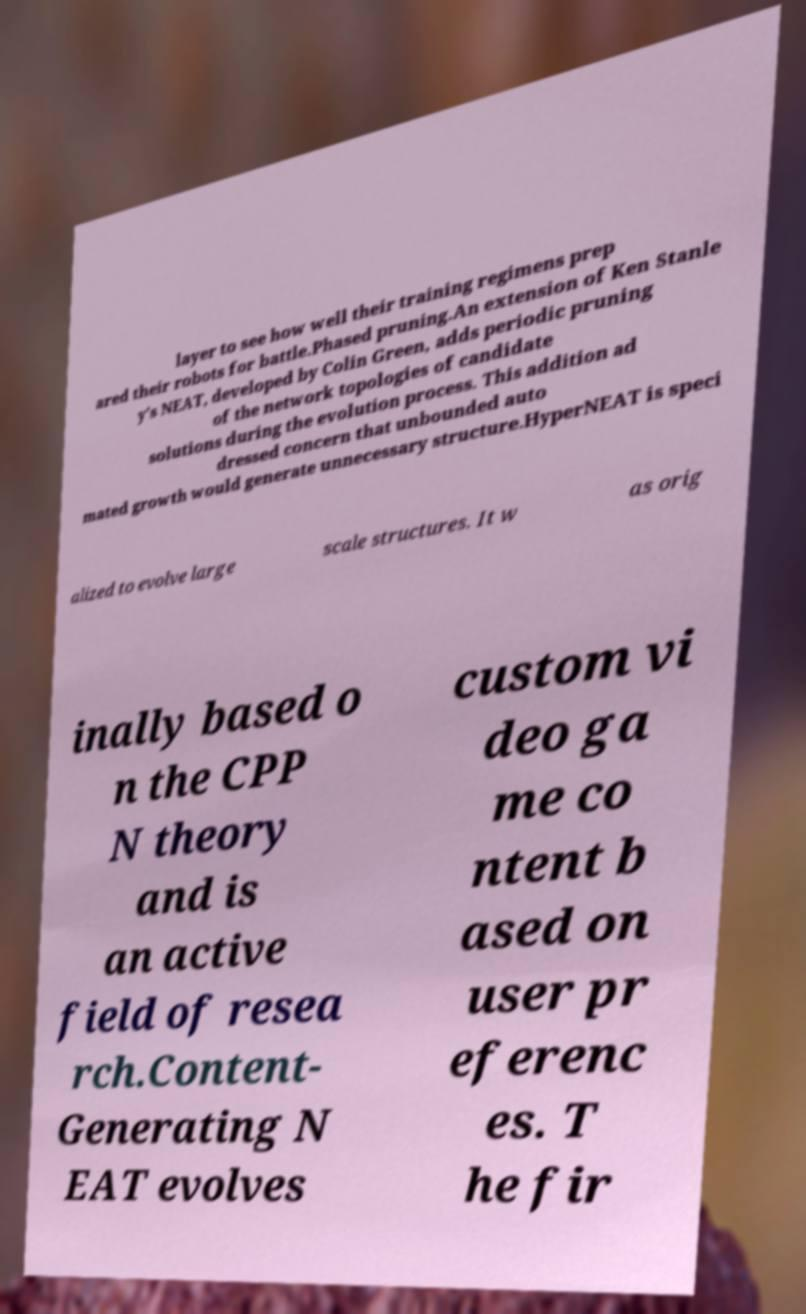Could you assist in decoding the text presented in this image and type it out clearly? layer to see how well their training regimens prep ared their robots for battle.Phased pruning.An extension of Ken Stanle y's NEAT, developed by Colin Green, adds periodic pruning of the network topologies of candidate solutions during the evolution process. This addition ad dressed concern that unbounded auto mated growth would generate unnecessary structure.HyperNEAT is speci alized to evolve large scale structures. It w as orig inally based o n the CPP N theory and is an active field of resea rch.Content- Generating N EAT evolves custom vi deo ga me co ntent b ased on user pr eferenc es. T he fir 